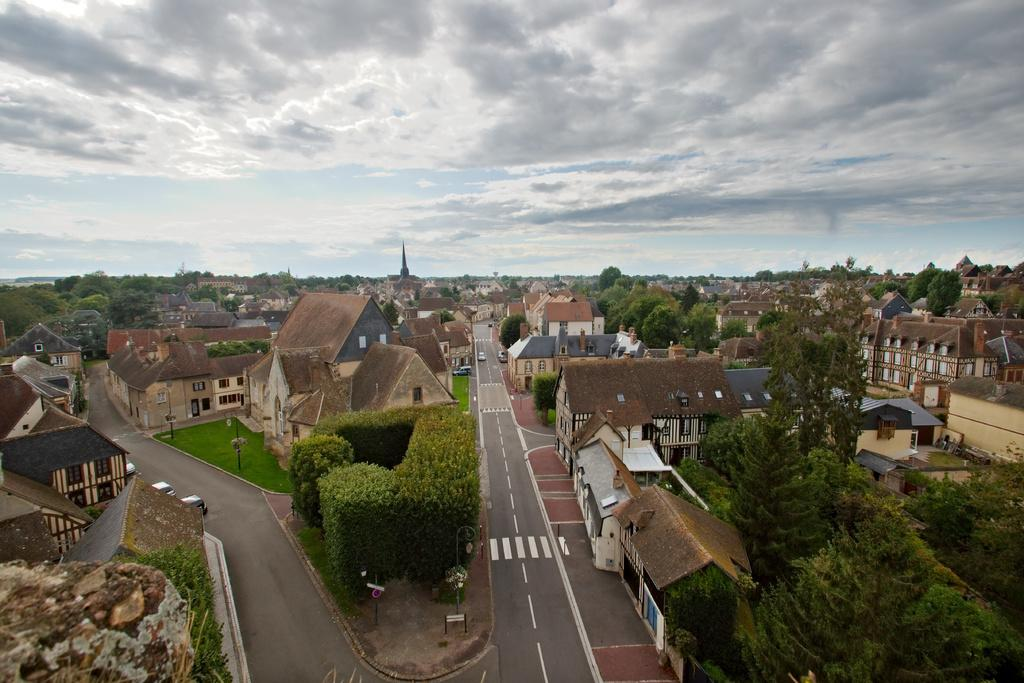What type of view is shown in the image? The image is an aerial view of a place. What natural elements can be seen in the image? There are trees and plants in the image. What man-made structures are visible in the image? There are roads, houses, and buildings in the image. What type of transportation can be seen in the image? There are vehicles in the image. What type of plants are being used for treatment in the image? There is no indication in the image that any plants are being used for treatment. How many girls can be seen playing in the image? There are no girls present in the image. 